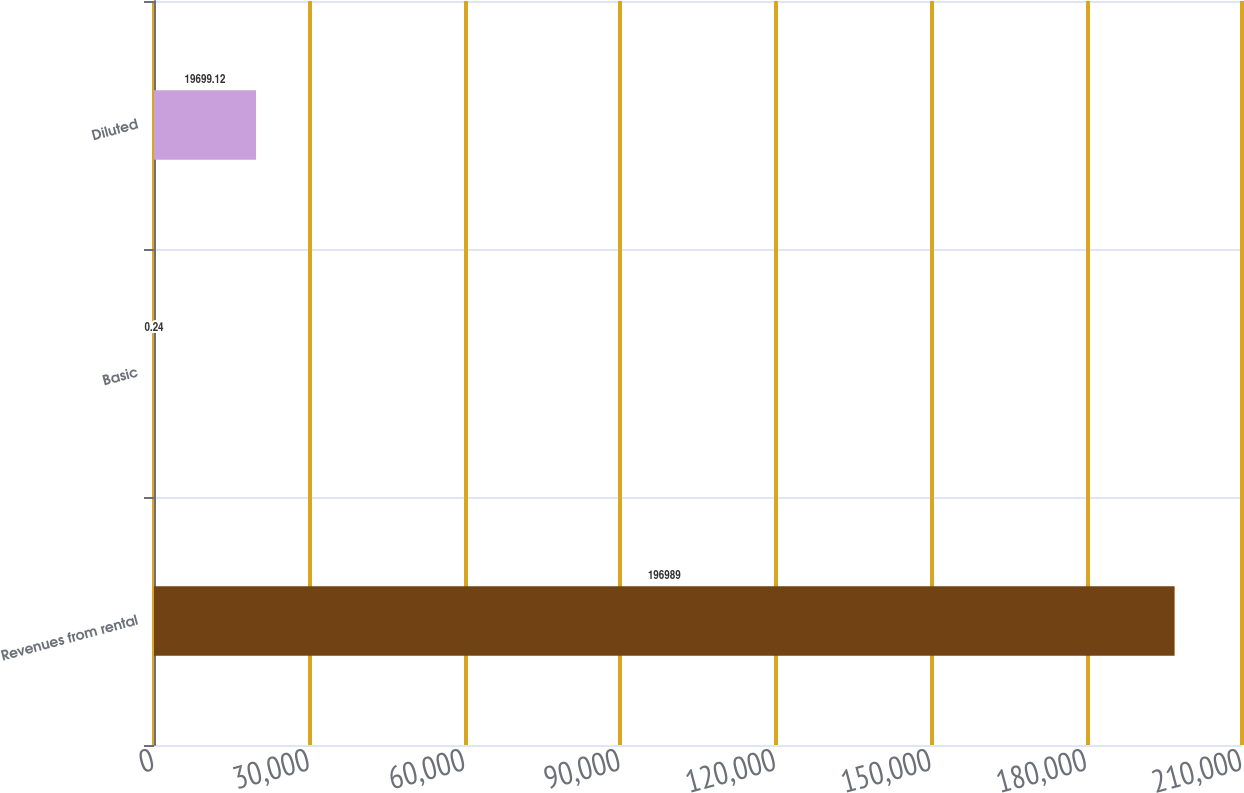Convert chart. <chart><loc_0><loc_0><loc_500><loc_500><bar_chart><fcel>Revenues from rental<fcel>Basic<fcel>Diluted<nl><fcel>196989<fcel>0.24<fcel>19699.1<nl></chart> 